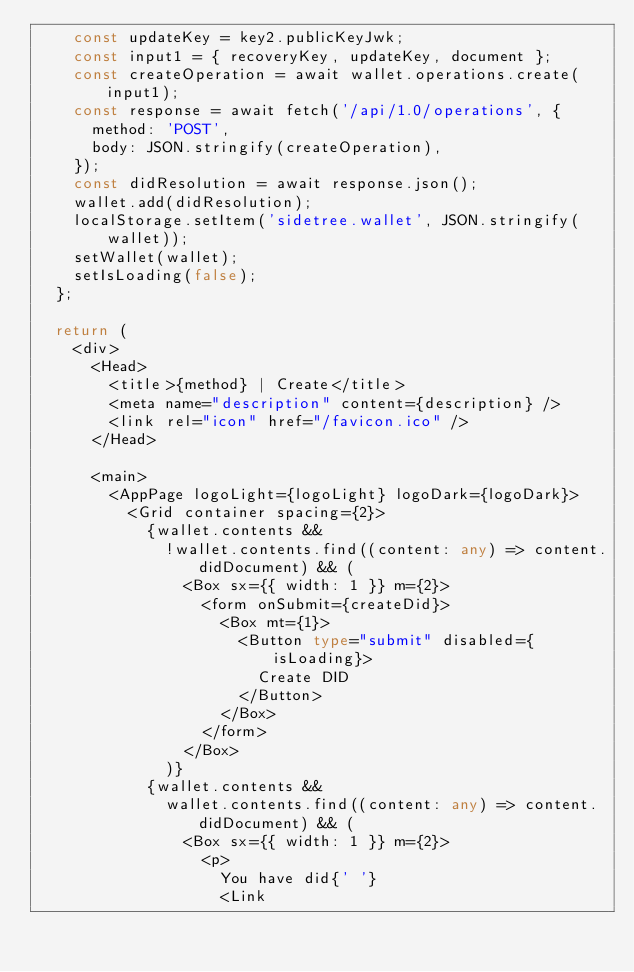<code> <loc_0><loc_0><loc_500><loc_500><_TypeScript_>    const updateKey = key2.publicKeyJwk;
    const input1 = { recoveryKey, updateKey, document };
    const createOperation = await wallet.operations.create(input1);
    const response = await fetch('/api/1.0/operations', {
      method: 'POST',
      body: JSON.stringify(createOperation),
    });
    const didResolution = await response.json();
    wallet.add(didResolution);
    localStorage.setItem('sidetree.wallet', JSON.stringify(wallet));
    setWallet(wallet);
    setIsLoading(false);
  };

  return (
    <div>
      <Head>
        <title>{method} | Create</title>
        <meta name="description" content={description} />
        <link rel="icon" href="/favicon.ico" />
      </Head>

      <main>
        <AppPage logoLight={logoLight} logoDark={logoDark}>
          <Grid container spacing={2}>
            {wallet.contents &&
              !wallet.contents.find((content: any) => content.didDocument) && (
                <Box sx={{ width: 1 }} m={2}>
                  <form onSubmit={createDid}>
                    <Box mt={1}>
                      <Button type="submit" disabled={isLoading}>
                        Create DID
                      </Button>
                    </Box>
                  </form>
                </Box>
              )}
            {wallet.contents &&
              wallet.contents.find((content: any) => content.didDocument) && (
                <Box sx={{ width: 1 }} m={2}>
                  <p>
                    You have did{' '}
                    <Link</code> 